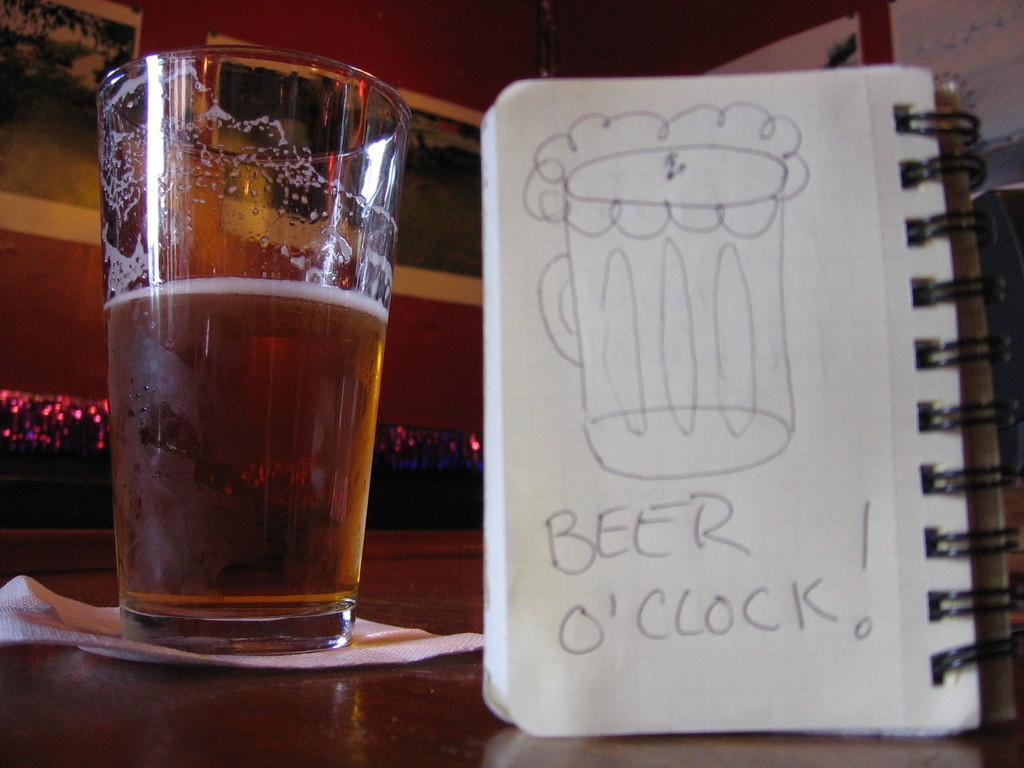<image>
Offer a succinct explanation of the picture presented. A half glass filled beer glass beside a notebook with a drawing of a beer that says Beer O'clock 